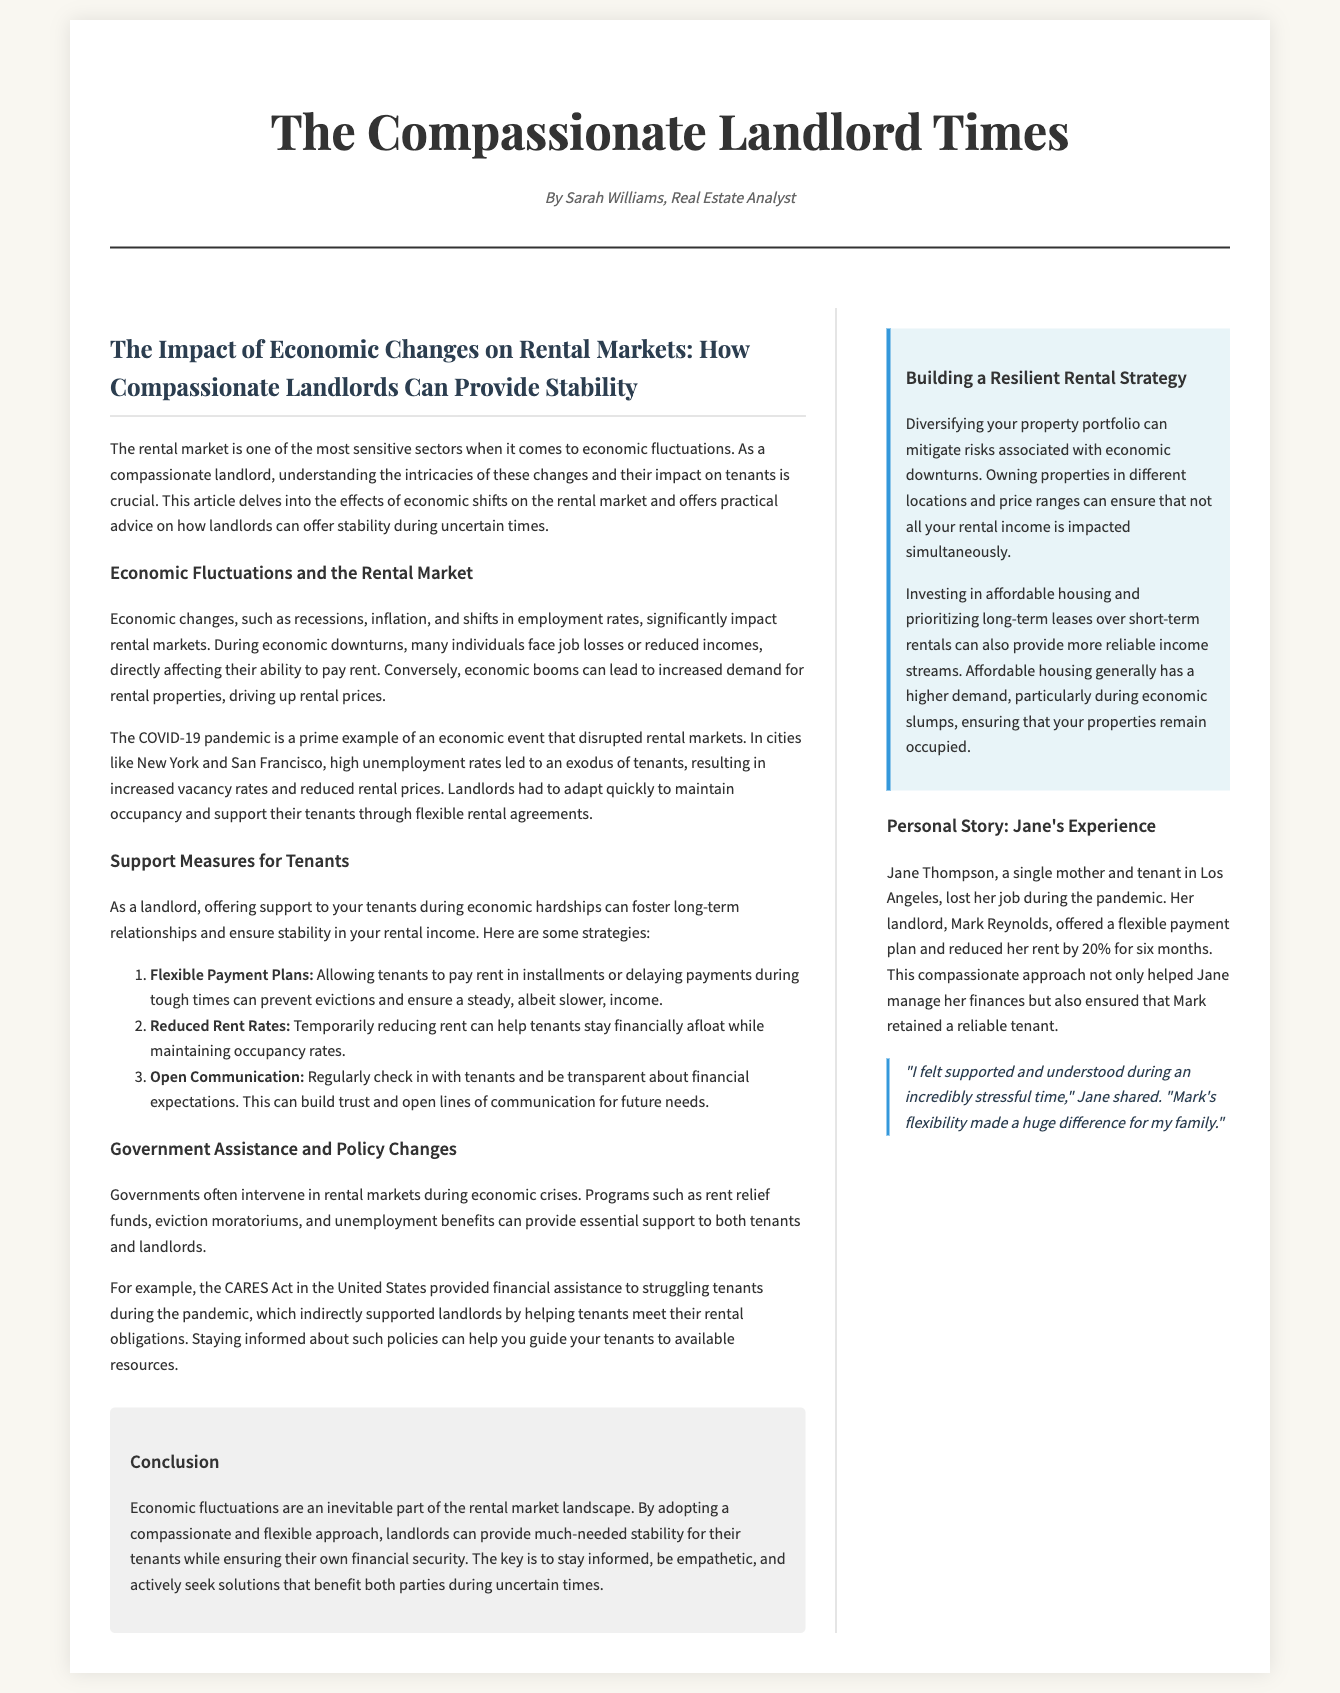What is the title of the article? The title is mentioned at the beginning of the article, presenting the main theme of the content.
Answer: The Impact of Economic Changes on Rental Markets: How Compassionate Landlords Can Provide Stability Who wrote the article? The byline emphasizes the author's name, providing credit for the analysis.
Answer: Sarah Williams What economic event is cited as an example affecting rental markets? The article discusses specific events that influenced rental markets, highlighting a significant economic disruption.
Answer: The COVID-19 pandemic What is one strategy landlords can use to support tenants during tough times? The article lists several strategies landlords can employ to help tenants manage financial difficulties.
Answer: Flexible Payment Plans Which government act is referenced for tenant support during economic crises? The text refers to a specific government policy that aided tenants during the pandemic.
Answer: The CARES Act What percentage was Jane's rent reduced by? This figure illustrates the specific adjustment made to Jane's rent during her financial hardship.
Answer: 20% What benefit is suggested for building a resilient rental strategy? The article mentions a key advantage of diversifying property portfolios to minimize economic risk.
Answer: Mitigating risks What is a key characteristic of landlords who adopt a compassionate approach? The article discusses the overall attitude and action of such landlords towards their tenants during challenges.
Answer: Empathy What can landlords stay informed about to better support their tenants? The section on government assistance implies the necessity for landlords to understand certain resources.
Answer: Policies 